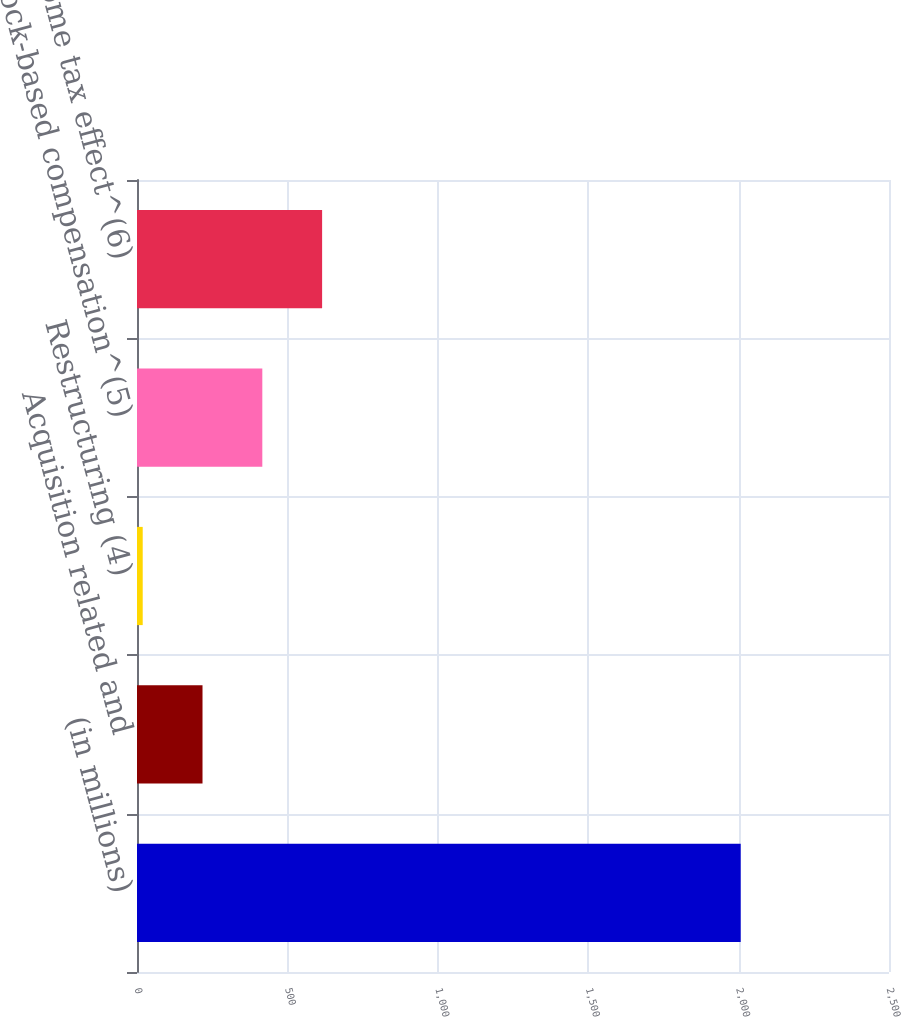Convert chart. <chart><loc_0><loc_0><loc_500><loc_500><bar_chart><fcel>(in millions)<fcel>Acquisition related and<fcel>Restructuring (4)<fcel>Stock-based compensation^(5)<fcel>Income tax effect^(6)<nl><fcel>2007<fcel>217.8<fcel>19<fcel>416.6<fcel>615.4<nl></chart> 